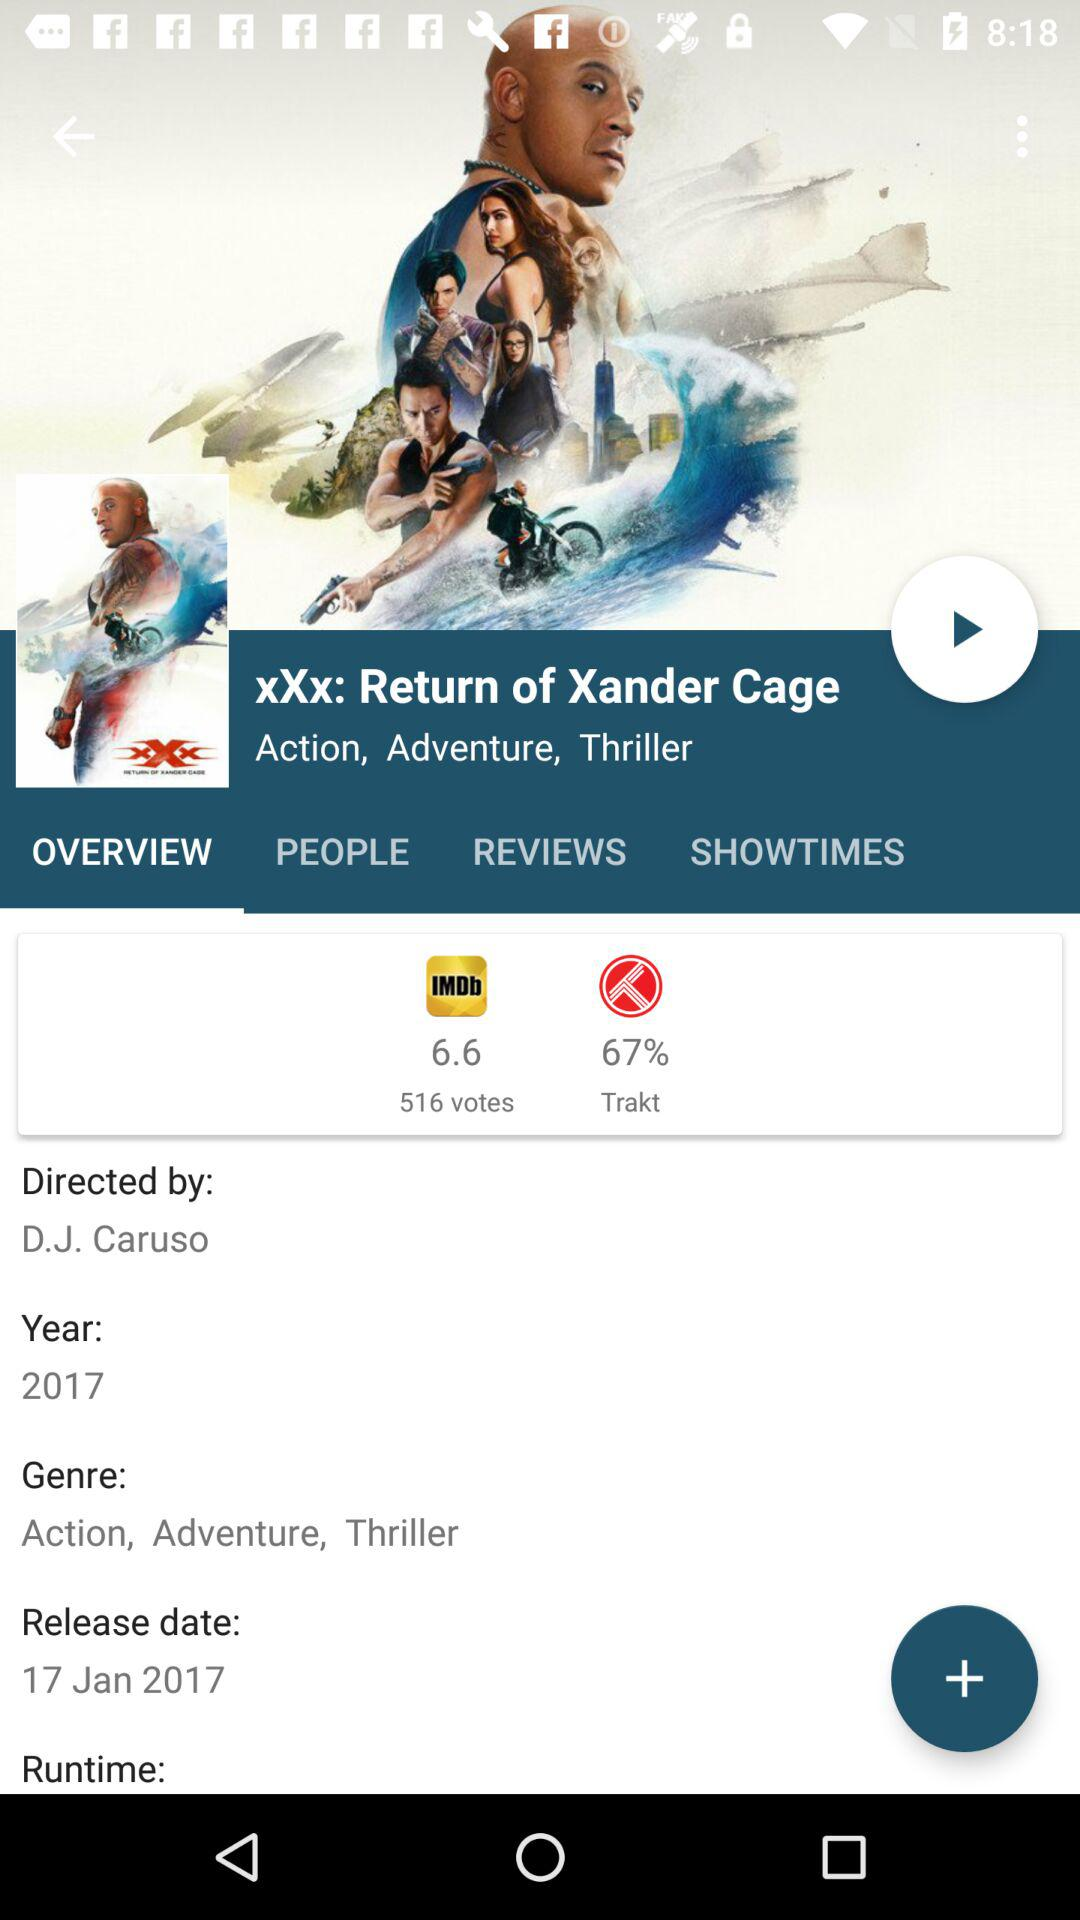What was the runtime of the movie?
When the provided information is insufficient, respond with <no answer>. <no answer> 